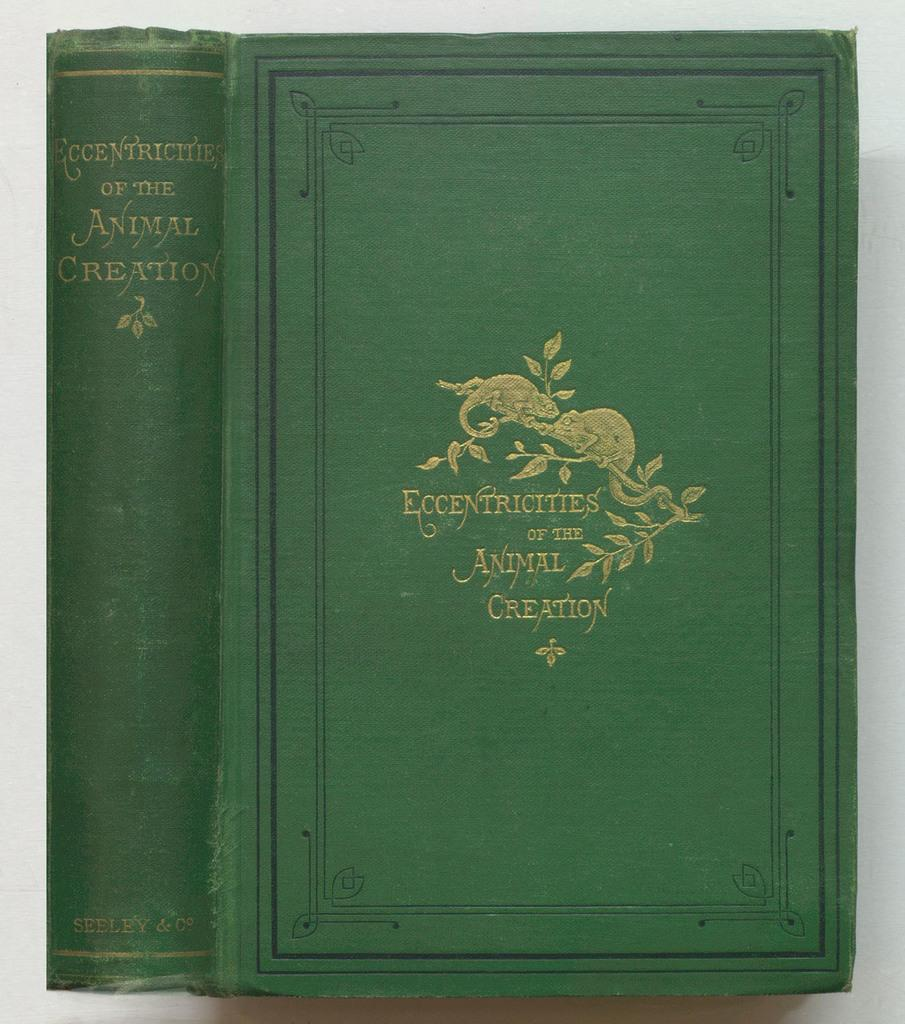Provide a one-sentence caption for the provided image. Two gold iguanas balance on a branch above the book title Eccentricities of the Animal Creation. 